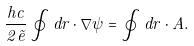<formula> <loc_0><loc_0><loc_500><loc_500>\frac { \hbar { c } } { 2 \tilde { e } } \oint d r \cdot \nabla \psi = \oint d r \cdot A .</formula> 